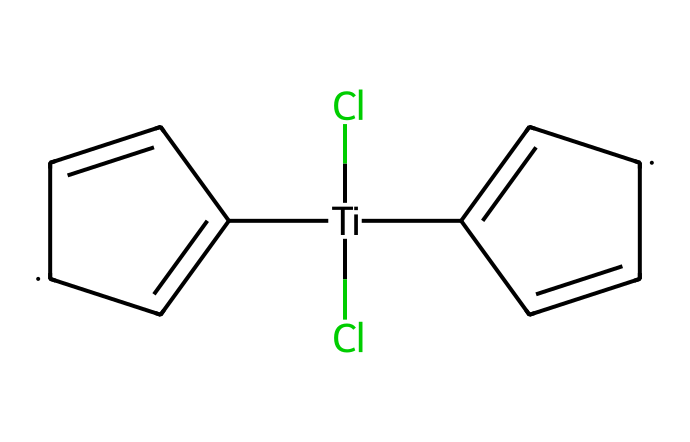What is the central metal atom in titanocene dichloride? The chemical structure reveals a titanium atom at the center, bonded to two chlorine atoms and two cyclopentadienyl (Cp) groups.
Answer: titanium How many chlorine atoms are present in the molecule? Inspecting the structure shows two chlorine atoms directly bonded to the titanium center, confirming the presence of two chlorines.
Answer: two What type of chemical bonding is primarily present in titanocene dichloride? The bonds observed between titanium and chlorine, as well as between titanium and the cyclopentadienyl ligands, indicate coordination bonding typical in organometallics.
Answer: coordination How many carbon atoms are in each cyclopentadienyl ring? Each cyclopentadienyl (Cp) ring structure has five carbon atoms, and there are two such rings in the molecule, confirming a total of ten.
Answer: ten What is the hybridization of the central titanium atom in titanocene dichloride? By analyzing the bonding environment around titanium, which forms bonds with two chlorines and two cyclopentadienyl ligands, we identify that the hybridization is dsp2.
Answer: dsp2 What type of reaction mechanism is typically associated with titanocene dichloride in catalytic converters? Titanocene dichloride acts as a catalyst in various reactions, commonly associated with coordination-insertion mechanisms utilized for controlling emissions.
Answer: coordination-insertion What functional role do the cyclopentadienyl groups play in titanocene dichloride? The cyclopentadienyl groups serve as electron-donating ligands that stabilize the titanium center, enhancing its catalytic properties.
Answer: electron-donating ligands 